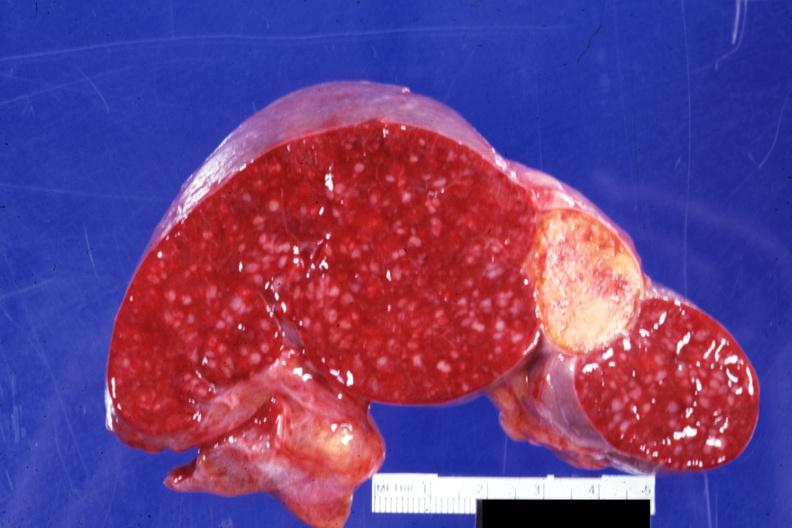s spleen present?
Answer the question using a single word or phrase. Yes 